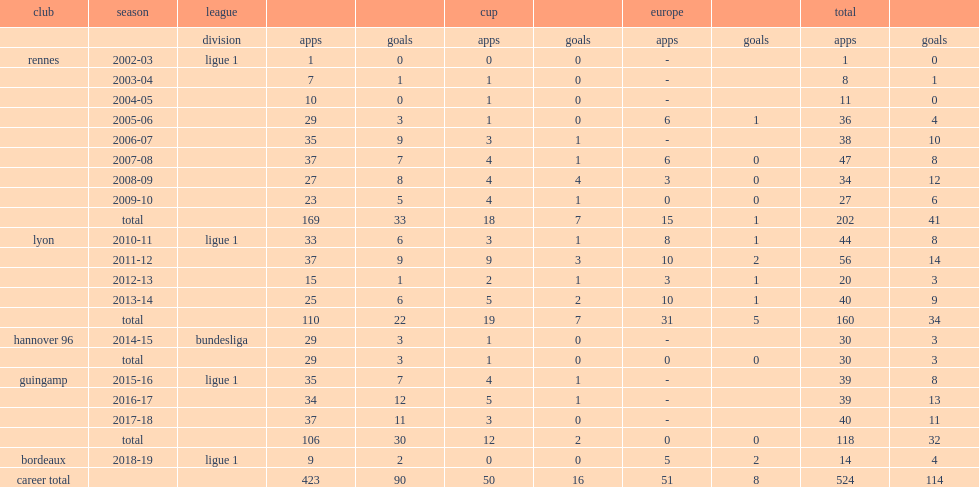In the 2009-10 season, which league did briand play for rennes? Ligue 1. 